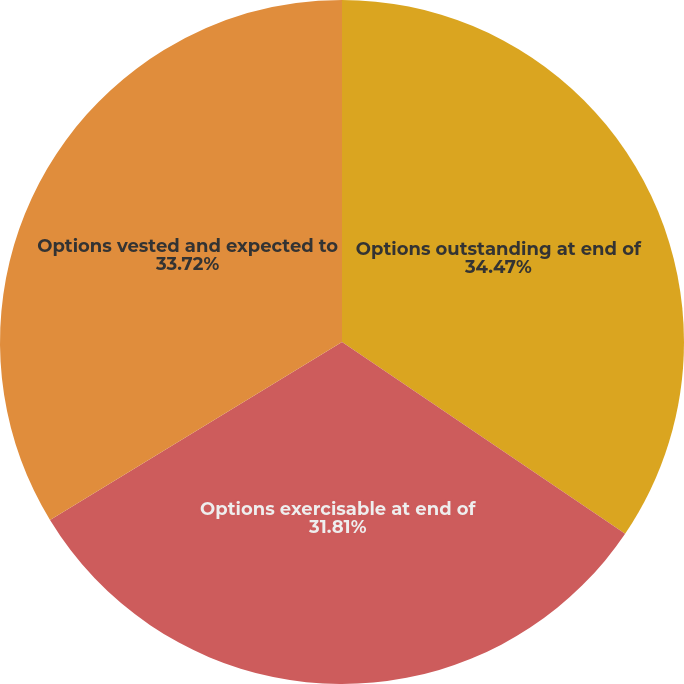Convert chart. <chart><loc_0><loc_0><loc_500><loc_500><pie_chart><fcel>Options outstanding at end of<fcel>Options exercisable at end of<fcel>Options vested and expected to<nl><fcel>34.48%<fcel>31.81%<fcel>33.72%<nl></chart> 